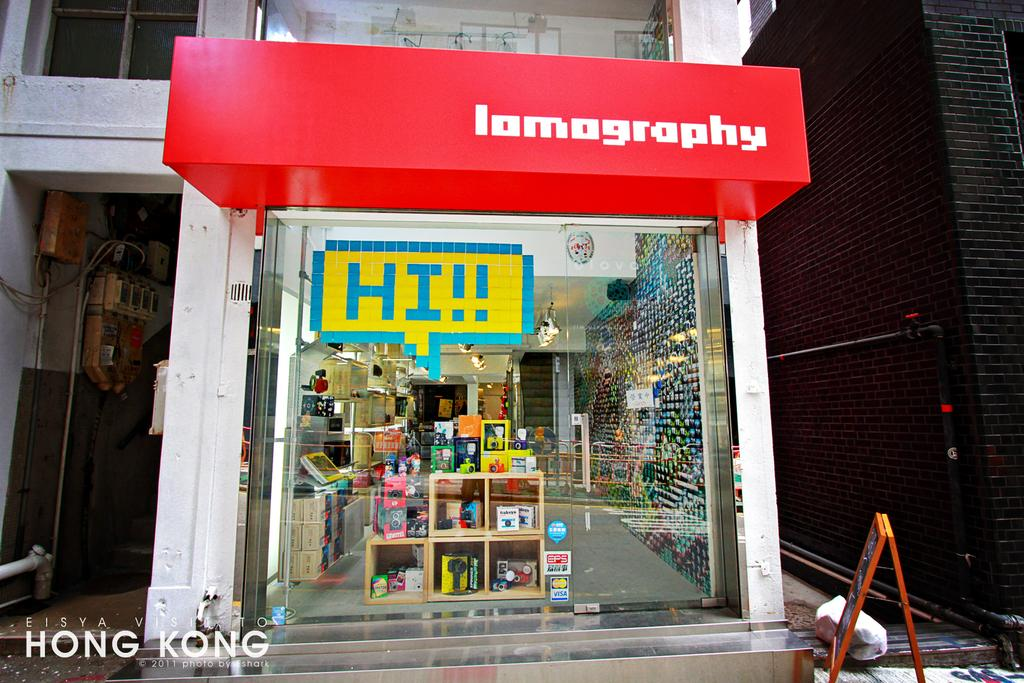<image>
Create a compact narrative representing the image presented. The oustide of a colourful and narrow shop called lamography in Hong Kong. 